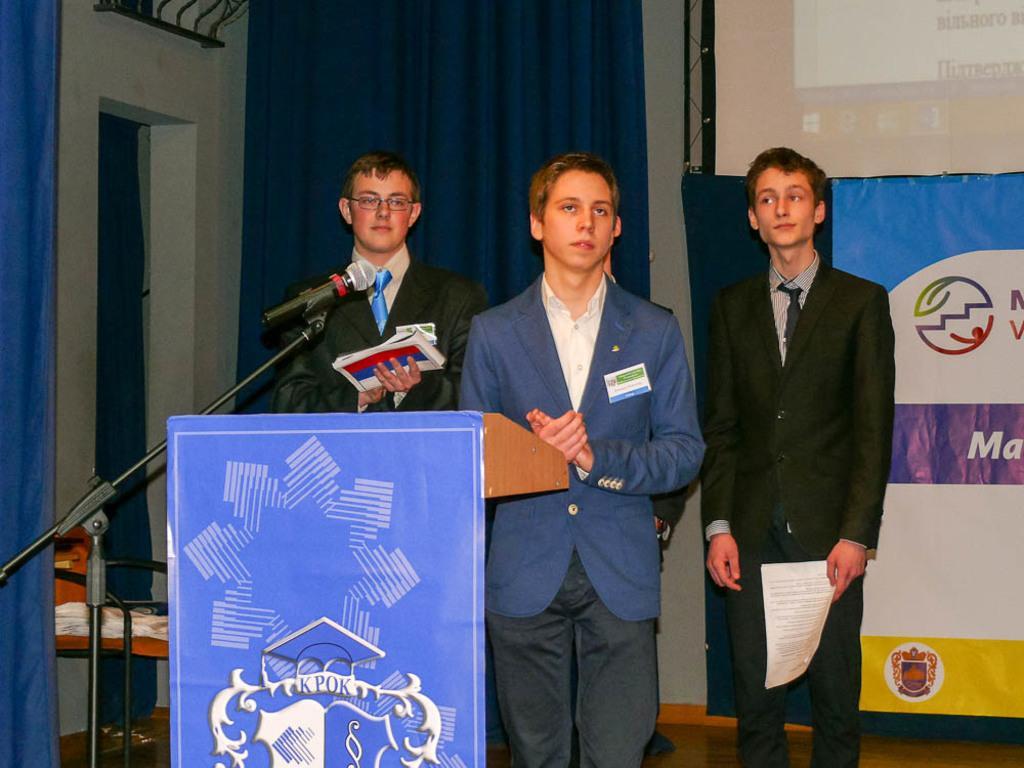Could you give a brief overview of what you see in this image? In this image we can see a few people, among them two persons are holding the objects, in front of them, we can see a podium and a mic, there are some curtains, also we can see a poster, chair and screen. 